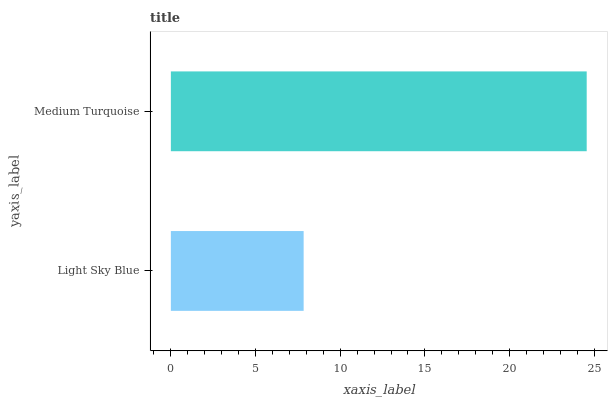Is Light Sky Blue the minimum?
Answer yes or no. Yes. Is Medium Turquoise the maximum?
Answer yes or no. Yes. Is Medium Turquoise the minimum?
Answer yes or no. No. Is Medium Turquoise greater than Light Sky Blue?
Answer yes or no. Yes. Is Light Sky Blue less than Medium Turquoise?
Answer yes or no. Yes. Is Light Sky Blue greater than Medium Turquoise?
Answer yes or no. No. Is Medium Turquoise less than Light Sky Blue?
Answer yes or no. No. Is Medium Turquoise the high median?
Answer yes or no. Yes. Is Light Sky Blue the low median?
Answer yes or no. Yes. Is Light Sky Blue the high median?
Answer yes or no. No. Is Medium Turquoise the low median?
Answer yes or no. No. 